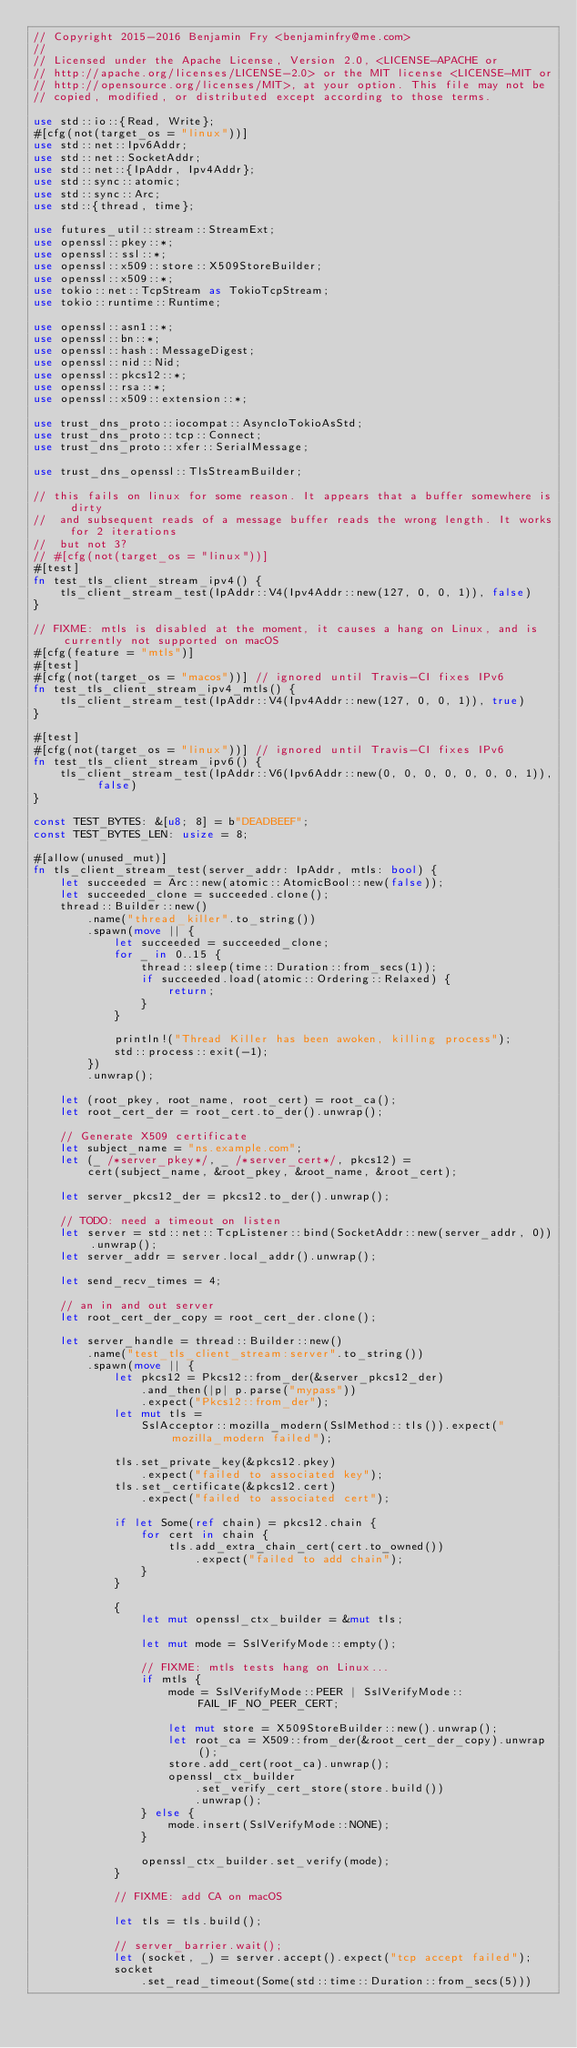Convert code to text. <code><loc_0><loc_0><loc_500><loc_500><_Rust_>// Copyright 2015-2016 Benjamin Fry <benjaminfry@me.com>
//
// Licensed under the Apache License, Version 2.0, <LICENSE-APACHE or
// http://apache.org/licenses/LICENSE-2.0> or the MIT license <LICENSE-MIT or
// http://opensource.org/licenses/MIT>, at your option. This file may not be
// copied, modified, or distributed except according to those terms.

use std::io::{Read, Write};
#[cfg(not(target_os = "linux"))]
use std::net::Ipv6Addr;
use std::net::SocketAddr;
use std::net::{IpAddr, Ipv4Addr};
use std::sync::atomic;
use std::sync::Arc;
use std::{thread, time};

use futures_util::stream::StreamExt;
use openssl::pkey::*;
use openssl::ssl::*;
use openssl::x509::store::X509StoreBuilder;
use openssl::x509::*;
use tokio::net::TcpStream as TokioTcpStream;
use tokio::runtime::Runtime;

use openssl::asn1::*;
use openssl::bn::*;
use openssl::hash::MessageDigest;
use openssl::nid::Nid;
use openssl::pkcs12::*;
use openssl::rsa::*;
use openssl::x509::extension::*;

use trust_dns_proto::iocompat::AsyncIoTokioAsStd;
use trust_dns_proto::tcp::Connect;
use trust_dns_proto::xfer::SerialMessage;

use trust_dns_openssl::TlsStreamBuilder;

// this fails on linux for some reason. It appears that a buffer somewhere is dirty
//  and subsequent reads of a message buffer reads the wrong length. It works for 2 iterations
//  but not 3?
// #[cfg(not(target_os = "linux"))]
#[test]
fn test_tls_client_stream_ipv4() {
    tls_client_stream_test(IpAddr::V4(Ipv4Addr::new(127, 0, 0, 1)), false)
}

// FIXME: mtls is disabled at the moment, it causes a hang on Linux, and is currently not supported on macOS
#[cfg(feature = "mtls")]
#[test]
#[cfg(not(target_os = "macos"))] // ignored until Travis-CI fixes IPv6
fn test_tls_client_stream_ipv4_mtls() {
    tls_client_stream_test(IpAddr::V4(Ipv4Addr::new(127, 0, 0, 1)), true)
}

#[test]
#[cfg(not(target_os = "linux"))] // ignored until Travis-CI fixes IPv6
fn test_tls_client_stream_ipv6() {
    tls_client_stream_test(IpAddr::V6(Ipv6Addr::new(0, 0, 0, 0, 0, 0, 0, 1)), false)
}

const TEST_BYTES: &[u8; 8] = b"DEADBEEF";
const TEST_BYTES_LEN: usize = 8;

#[allow(unused_mut)]
fn tls_client_stream_test(server_addr: IpAddr, mtls: bool) {
    let succeeded = Arc::new(atomic::AtomicBool::new(false));
    let succeeded_clone = succeeded.clone();
    thread::Builder::new()
        .name("thread_killer".to_string())
        .spawn(move || {
            let succeeded = succeeded_clone;
            for _ in 0..15 {
                thread::sleep(time::Duration::from_secs(1));
                if succeeded.load(atomic::Ordering::Relaxed) {
                    return;
                }
            }

            println!("Thread Killer has been awoken, killing process");
            std::process::exit(-1);
        })
        .unwrap();

    let (root_pkey, root_name, root_cert) = root_ca();
    let root_cert_der = root_cert.to_der().unwrap();

    // Generate X509 certificate
    let subject_name = "ns.example.com";
    let (_ /*server_pkey*/, _ /*server_cert*/, pkcs12) =
        cert(subject_name, &root_pkey, &root_name, &root_cert);

    let server_pkcs12_der = pkcs12.to_der().unwrap();

    // TODO: need a timeout on listen
    let server = std::net::TcpListener::bind(SocketAddr::new(server_addr, 0)).unwrap();
    let server_addr = server.local_addr().unwrap();

    let send_recv_times = 4;

    // an in and out server
    let root_cert_der_copy = root_cert_der.clone();

    let server_handle = thread::Builder::new()
        .name("test_tls_client_stream:server".to_string())
        .spawn(move || {
            let pkcs12 = Pkcs12::from_der(&server_pkcs12_der)
                .and_then(|p| p.parse("mypass"))
                .expect("Pkcs12::from_der");
            let mut tls =
                SslAcceptor::mozilla_modern(SslMethod::tls()).expect("mozilla_modern failed");

            tls.set_private_key(&pkcs12.pkey)
                .expect("failed to associated key");
            tls.set_certificate(&pkcs12.cert)
                .expect("failed to associated cert");

            if let Some(ref chain) = pkcs12.chain {
                for cert in chain {
                    tls.add_extra_chain_cert(cert.to_owned())
                        .expect("failed to add chain");
                }
            }

            {
                let mut openssl_ctx_builder = &mut tls;

                let mut mode = SslVerifyMode::empty();

                // FIXME: mtls tests hang on Linux...
                if mtls {
                    mode = SslVerifyMode::PEER | SslVerifyMode::FAIL_IF_NO_PEER_CERT;

                    let mut store = X509StoreBuilder::new().unwrap();
                    let root_ca = X509::from_der(&root_cert_der_copy).unwrap();
                    store.add_cert(root_ca).unwrap();
                    openssl_ctx_builder
                        .set_verify_cert_store(store.build())
                        .unwrap();
                } else {
                    mode.insert(SslVerifyMode::NONE);
                }

                openssl_ctx_builder.set_verify(mode);
            }

            // FIXME: add CA on macOS

            let tls = tls.build();

            // server_barrier.wait();
            let (socket, _) = server.accept().expect("tcp accept failed");
            socket
                .set_read_timeout(Some(std::time::Duration::from_secs(5)))</code> 